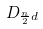Convert formula to latex. <formula><loc_0><loc_0><loc_500><loc_500>D _ { \frac { n } { 2 } d }</formula> 